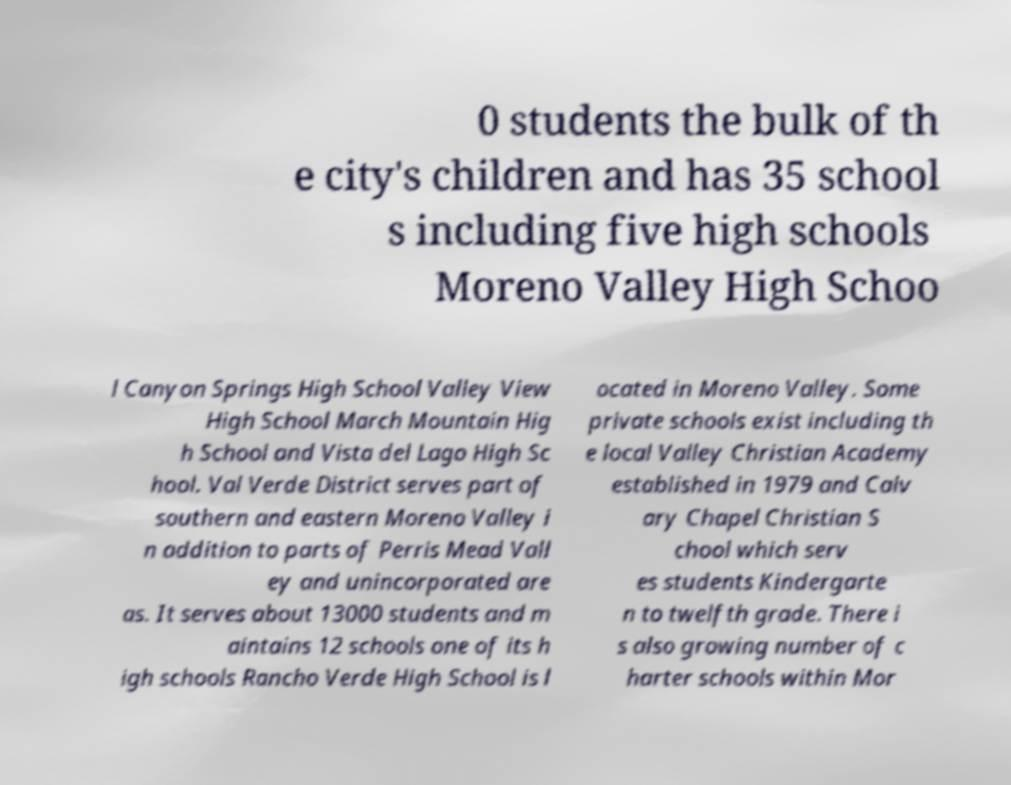For documentation purposes, I need the text within this image transcribed. Could you provide that? 0 students the bulk of th e city's children and has 35 school s including five high schools Moreno Valley High Schoo l Canyon Springs High School Valley View High School March Mountain Hig h School and Vista del Lago High Sc hool. Val Verde District serves part of southern and eastern Moreno Valley i n addition to parts of Perris Mead Vall ey and unincorporated are as. It serves about 13000 students and m aintains 12 schools one of its h igh schools Rancho Verde High School is l ocated in Moreno Valley. Some private schools exist including th e local Valley Christian Academy established in 1979 and Calv ary Chapel Christian S chool which serv es students Kindergarte n to twelfth grade. There i s also growing number of c harter schools within Mor 